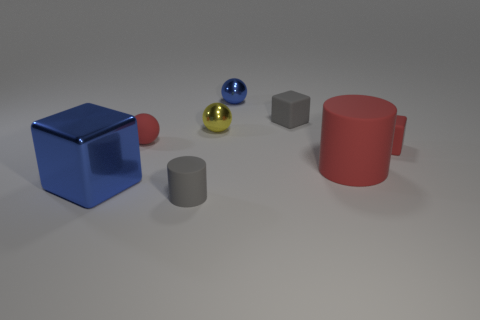Do the large rubber cylinder and the tiny matte thing that is to the right of the big red cylinder have the same color?
Your response must be concise. Yes. What color is the metal thing that is behind the tiny rubber ball and left of the small blue metallic sphere?
Keep it short and to the point. Yellow. What is the cube that is behind the matte cube on the right side of the rubber block that is on the left side of the red cylinder made of?
Offer a very short reply. Rubber. What is the material of the tiny gray cube?
Offer a terse response. Rubber. There is a blue thing that is the same shape as the yellow metal thing; what size is it?
Your answer should be very brief. Small. Is the big matte cylinder the same color as the tiny matte ball?
Make the answer very short. Yes. What number of other things are there of the same material as the small blue thing
Offer a very short reply. 2. Are there an equal number of tiny matte balls in front of the gray rubber cylinder and brown shiny cylinders?
Your answer should be compact. Yes. Do the cube that is on the left side of the yellow sphere and the tiny blue object have the same size?
Give a very brief answer. No. There is a yellow shiny object; what number of tiny rubber things are on the right side of it?
Give a very brief answer. 2. 